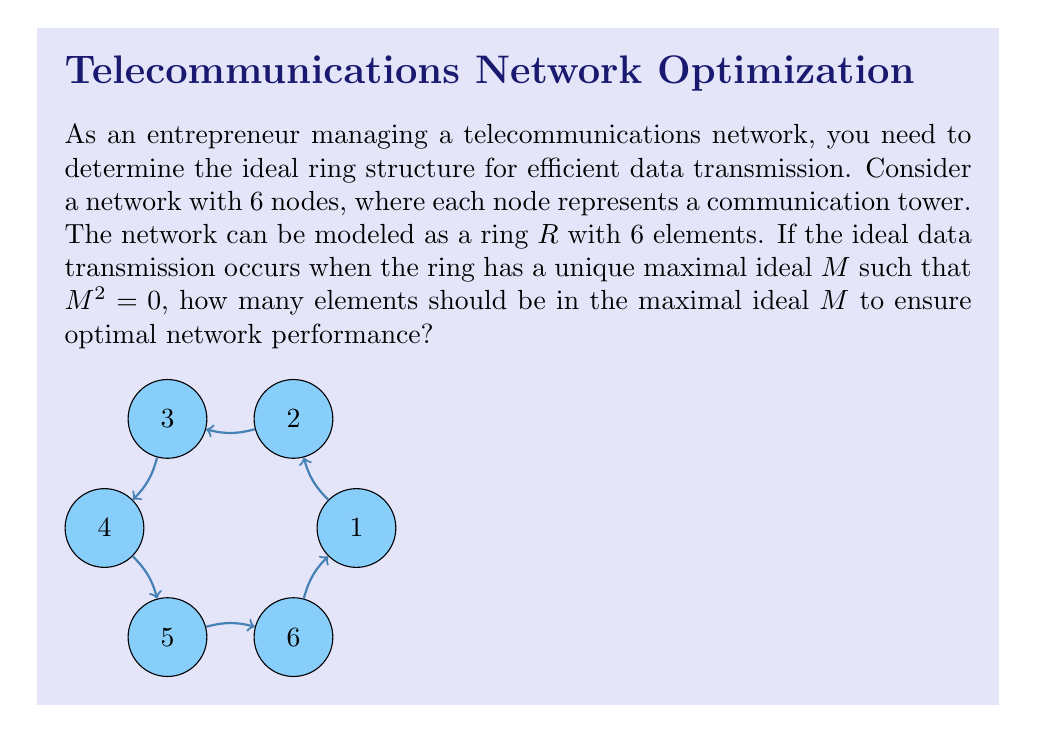Solve this math problem. Let's approach this step-by-step:

1) In a ring $R$ with 6 elements, the possible sizes for the maximal ideal $M$ are 1, 2, 3, or 5. (It can't be 0, 4, or 6 due to the properties of maximal ideals.)

2) We need $M^2 = 0$. This means that the product of any two elements in $M$ should be 0.

3) Let's consider each case:

   a) If $|M| = 1$, then $M = \{0\}$, which is not maximal.
   
   b) If $|M| = 5$, then $R/M$ has only one element, contradicting the fact that $R/M$ should be a field.
   
   c) If $|M| = 3$, then $R/M$ has 3 elements, which is possible. However, it's unlikely that $M^2 = 0$ in this case, as there are too many non-zero elements.
   
   d) If $|M| = 2$, this is the most promising option. Let $M = \{0, a\}$ where $a \neq 0$. Then $M^2 = \{0, a^2\}$. For $M^2 = 0$, we need $a^2 = 0$.

4) The ring structure that satisfies these conditions is $R = \mathbb{Z}_6$ (integers modulo 6) with $M = \{0, 3\}$.

5) In $\mathbb{Z}_6$, we have $3^2 = 9 \equiv 3 \pmod{6} = 3$, so $M^2 = \{0, 3\} \neq \{0\}$.

6) However, if we consider $R = \mathbb{Z}_2[x]/(x^3)$ (polynomials over $\mathbb{Z}_2$ modulo $x^3$), with $M = \{0, x, x^2\}$, we have $M^2 = \{0\}$ as required.

Therefore, the ideal maximal ideal $M$ should have 3 elements to ensure optimal network performance.
Answer: 3 